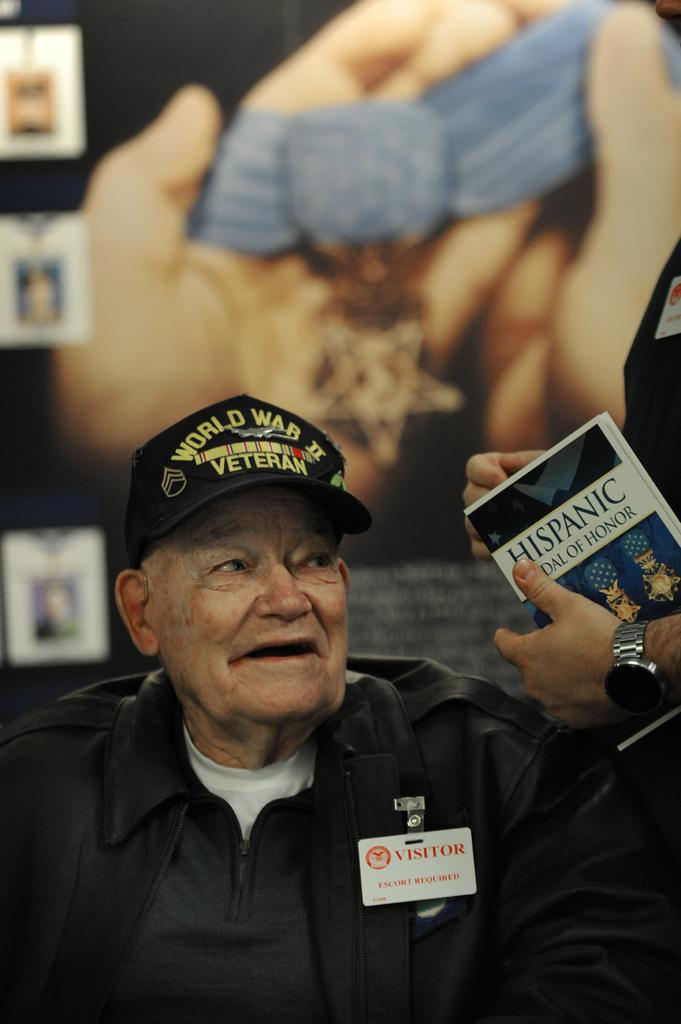What is the main subject of the image? There is a person in the image. What is the person wearing? The person is wearing a black dress and a black cap. What is the person holding? The person is holding a book. Can you describe the person's hand on the back side of the image? The person's hand on the back side of the image is blurred. What type of cast can be seen on the person's leg in the image? There is no cast visible on the person's leg in the image. How many light bulbs are present in the image? There are no light bulbs present in the image. 